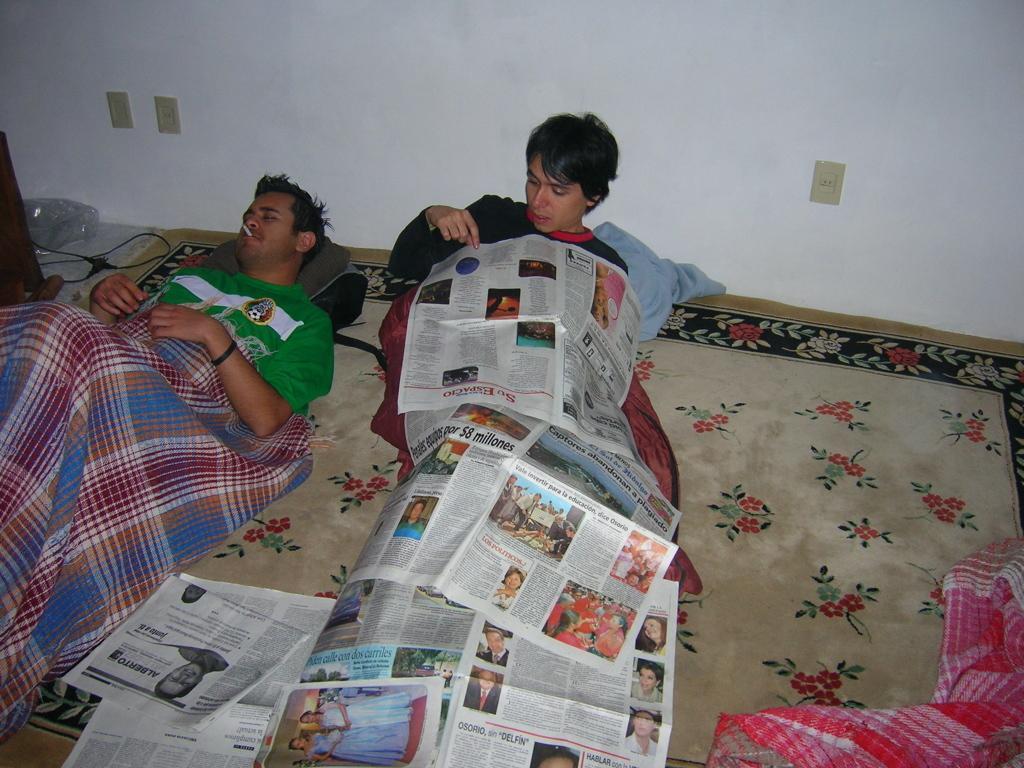In one or two sentences, can you explain what this image depicts? Here in this picture we can see a couple of men laying on the mattress present on the floor over there and they are having blankets on them and we can see news papers present all over there and we can see sockets on the wall present over there. 